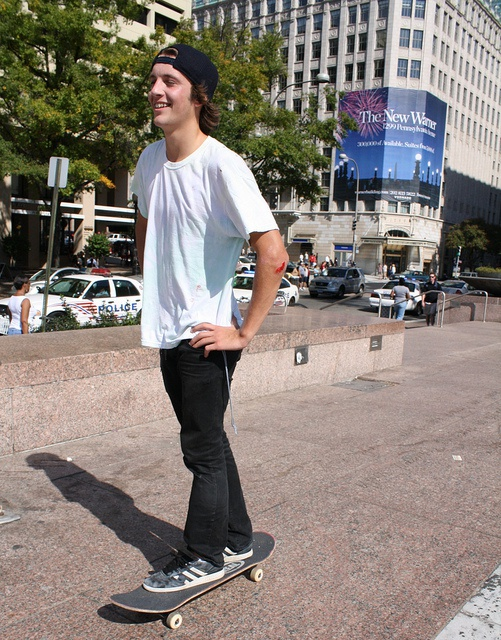Describe the objects in this image and their specific colors. I can see people in olive, black, white, darkgray, and lightpink tones, skateboard in olive, gray, black, darkgray, and ivory tones, car in olive, white, black, gray, and darkgray tones, car in olive, black, gray, and blue tones, and people in olive, lavender, black, brown, and darkgray tones in this image. 